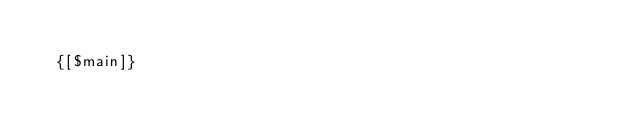<code> <loc_0><loc_0><loc_500><loc_500><_HTML_>
  {[$main]}
</code> 